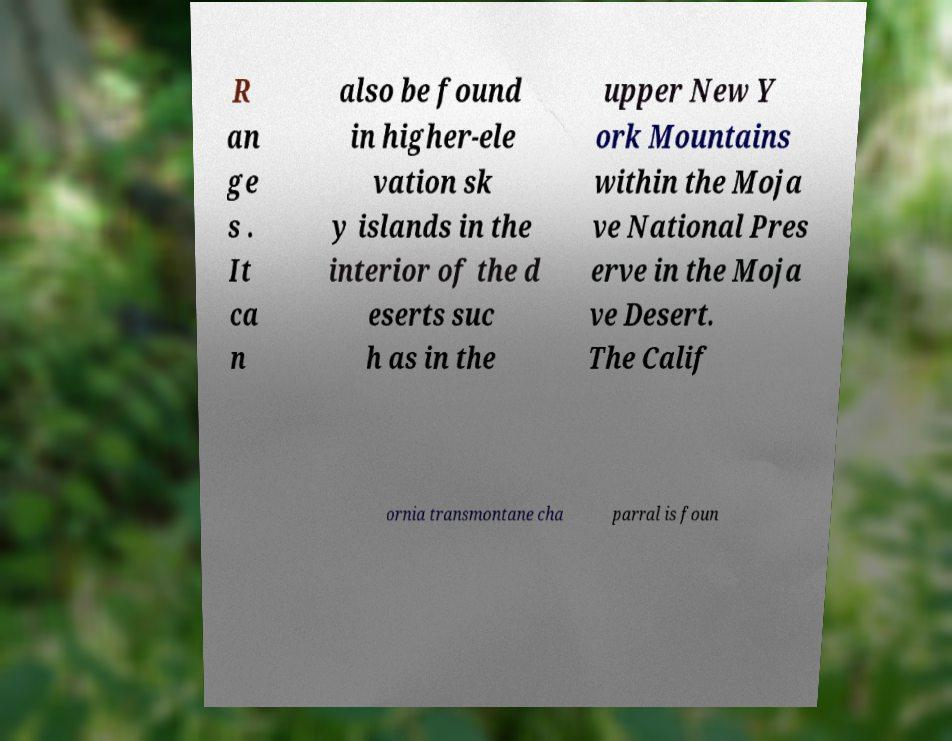Can you accurately transcribe the text from the provided image for me? R an ge s . It ca n also be found in higher-ele vation sk y islands in the interior of the d eserts suc h as in the upper New Y ork Mountains within the Moja ve National Pres erve in the Moja ve Desert. The Calif ornia transmontane cha parral is foun 